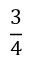<formula> <loc_0><loc_0><loc_500><loc_500>\frac { 3 } { 4 }</formula> 